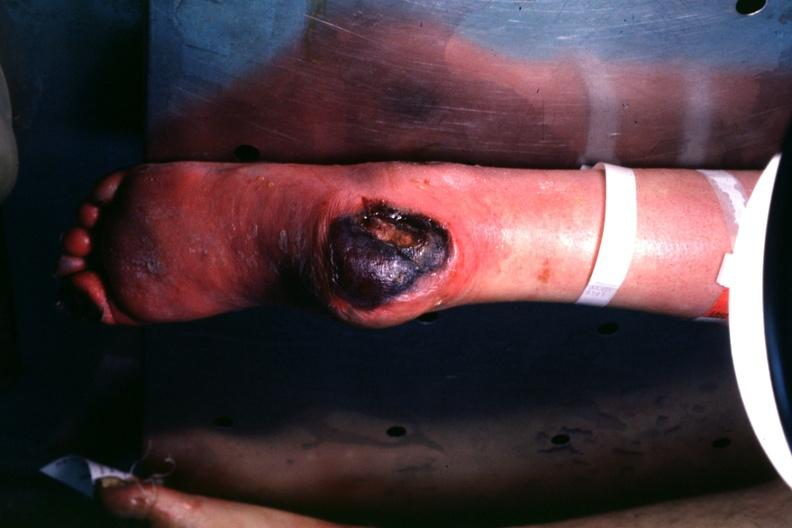s cardiovascular present?
Answer the question using a single word or phrase. No 